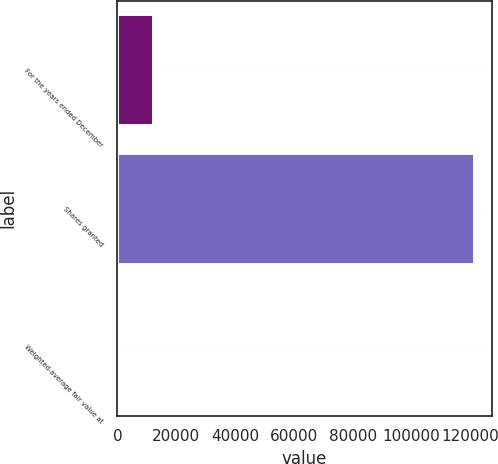Convert chart to OTSL. <chart><loc_0><loc_0><loc_500><loc_500><bar_chart><fcel>For the years ended December<fcel>Shares granted<fcel>Weighted-average fair value at<nl><fcel>12153.1<fcel>121230<fcel>33.4<nl></chart> 